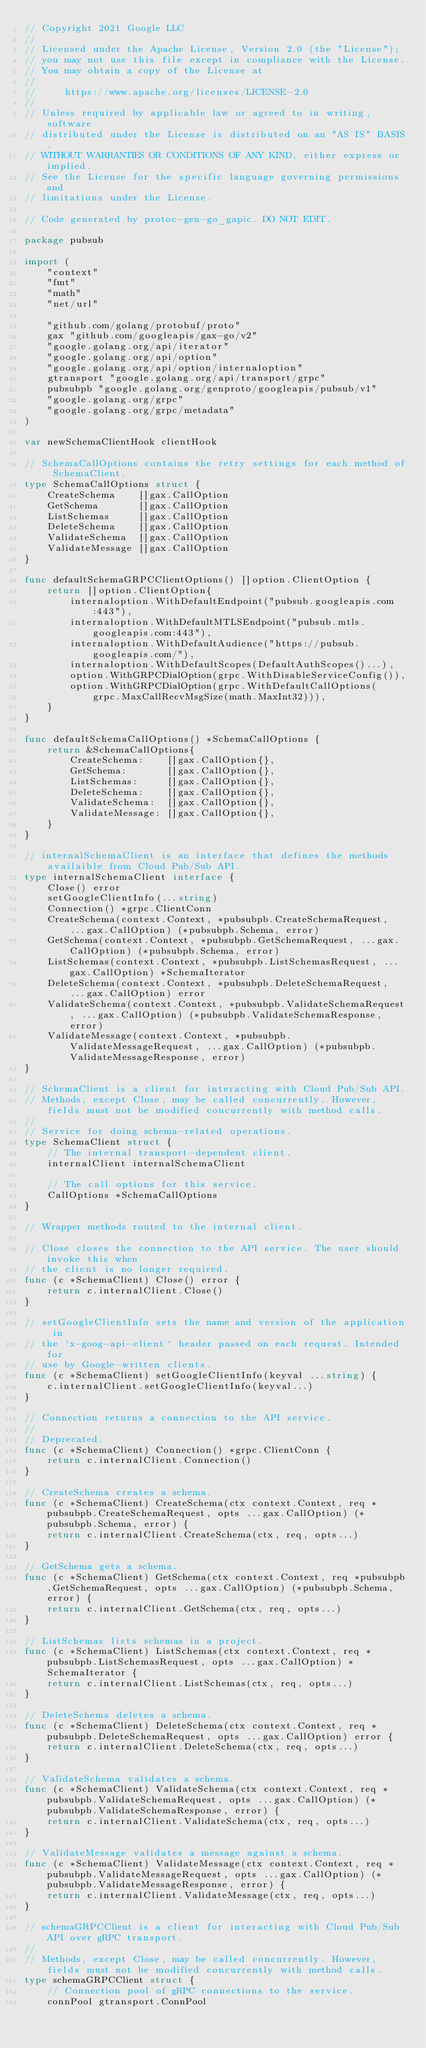Convert code to text. <code><loc_0><loc_0><loc_500><loc_500><_Go_>// Copyright 2021 Google LLC
//
// Licensed under the Apache License, Version 2.0 (the "License");
// you may not use this file except in compliance with the License.
// You may obtain a copy of the License at
//
//     https://www.apache.org/licenses/LICENSE-2.0
//
// Unless required by applicable law or agreed to in writing, software
// distributed under the License is distributed on an "AS IS" BASIS,
// WITHOUT WARRANTIES OR CONDITIONS OF ANY KIND, either express or implied.
// See the License for the specific language governing permissions and
// limitations under the License.

// Code generated by protoc-gen-go_gapic. DO NOT EDIT.

package pubsub

import (
	"context"
	"fmt"
	"math"
	"net/url"

	"github.com/golang/protobuf/proto"
	gax "github.com/googleapis/gax-go/v2"
	"google.golang.org/api/iterator"
	"google.golang.org/api/option"
	"google.golang.org/api/option/internaloption"
	gtransport "google.golang.org/api/transport/grpc"
	pubsubpb "google.golang.org/genproto/googleapis/pubsub/v1"
	"google.golang.org/grpc"
	"google.golang.org/grpc/metadata"
)

var newSchemaClientHook clientHook

// SchemaCallOptions contains the retry settings for each method of SchemaClient.
type SchemaCallOptions struct {
	CreateSchema    []gax.CallOption
	GetSchema       []gax.CallOption
	ListSchemas     []gax.CallOption
	DeleteSchema    []gax.CallOption
	ValidateSchema  []gax.CallOption
	ValidateMessage []gax.CallOption
}

func defaultSchemaGRPCClientOptions() []option.ClientOption {
	return []option.ClientOption{
		internaloption.WithDefaultEndpoint("pubsub.googleapis.com:443"),
		internaloption.WithDefaultMTLSEndpoint("pubsub.mtls.googleapis.com:443"),
		internaloption.WithDefaultAudience("https://pubsub.googleapis.com/"),
		internaloption.WithDefaultScopes(DefaultAuthScopes()...),
		option.WithGRPCDialOption(grpc.WithDisableServiceConfig()),
		option.WithGRPCDialOption(grpc.WithDefaultCallOptions(
			grpc.MaxCallRecvMsgSize(math.MaxInt32))),
	}
}

func defaultSchemaCallOptions() *SchemaCallOptions {
	return &SchemaCallOptions{
		CreateSchema:    []gax.CallOption{},
		GetSchema:       []gax.CallOption{},
		ListSchemas:     []gax.CallOption{},
		DeleteSchema:    []gax.CallOption{},
		ValidateSchema:  []gax.CallOption{},
		ValidateMessage: []gax.CallOption{},
	}
}

// internalSchemaClient is an interface that defines the methods availaible from Cloud Pub/Sub API.
type internalSchemaClient interface {
	Close() error
	setGoogleClientInfo(...string)
	Connection() *grpc.ClientConn
	CreateSchema(context.Context, *pubsubpb.CreateSchemaRequest, ...gax.CallOption) (*pubsubpb.Schema, error)
	GetSchema(context.Context, *pubsubpb.GetSchemaRequest, ...gax.CallOption) (*pubsubpb.Schema, error)
	ListSchemas(context.Context, *pubsubpb.ListSchemasRequest, ...gax.CallOption) *SchemaIterator
	DeleteSchema(context.Context, *pubsubpb.DeleteSchemaRequest, ...gax.CallOption) error
	ValidateSchema(context.Context, *pubsubpb.ValidateSchemaRequest, ...gax.CallOption) (*pubsubpb.ValidateSchemaResponse, error)
	ValidateMessage(context.Context, *pubsubpb.ValidateMessageRequest, ...gax.CallOption) (*pubsubpb.ValidateMessageResponse, error)
}

// SchemaClient is a client for interacting with Cloud Pub/Sub API.
// Methods, except Close, may be called concurrently. However, fields must not be modified concurrently with method calls.
//
// Service for doing schema-related operations.
type SchemaClient struct {
	// The internal transport-dependent client.
	internalClient internalSchemaClient

	// The call options for this service.
	CallOptions *SchemaCallOptions
}

// Wrapper methods routed to the internal client.

// Close closes the connection to the API service. The user should invoke this when
// the client is no longer required.
func (c *SchemaClient) Close() error {
	return c.internalClient.Close()
}

// setGoogleClientInfo sets the name and version of the application in
// the `x-goog-api-client` header passed on each request. Intended for
// use by Google-written clients.
func (c *SchemaClient) setGoogleClientInfo(keyval ...string) {
	c.internalClient.setGoogleClientInfo(keyval...)
}

// Connection returns a connection to the API service.
//
// Deprecated.
func (c *SchemaClient) Connection() *grpc.ClientConn {
	return c.internalClient.Connection()
}

// CreateSchema creates a schema.
func (c *SchemaClient) CreateSchema(ctx context.Context, req *pubsubpb.CreateSchemaRequest, opts ...gax.CallOption) (*pubsubpb.Schema, error) {
	return c.internalClient.CreateSchema(ctx, req, opts...)
}

// GetSchema gets a schema.
func (c *SchemaClient) GetSchema(ctx context.Context, req *pubsubpb.GetSchemaRequest, opts ...gax.CallOption) (*pubsubpb.Schema, error) {
	return c.internalClient.GetSchema(ctx, req, opts...)
}

// ListSchemas lists schemas in a project.
func (c *SchemaClient) ListSchemas(ctx context.Context, req *pubsubpb.ListSchemasRequest, opts ...gax.CallOption) *SchemaIterator {
	return c.internalClient.ListSchemas(ctx, req, opts...)
}

// DeleteSchema deletes a schema.
func (c *SchemaClient) DeleteSchema(ctx context.Context, req *pubsubpb.DeleteSchemaRequest, opts ...gax.CallOption) error {
	return c.internalClient.DeleteSchema(ctx, req, opts...)
}

// ValidateSchema validates a schema.
func (c *SchemaClient) ValidateSchema(ctx context.Context, req *pubsubpb.ValidateSchemaRequest, opts ...gax.CallOption) (*pubsubpb.ValidateSchemaResponse, error) {
	return c.internalClient.ValidateSchema(ctx, req, opts...)
}

// ValidateMessage validates a message against a schema.
func (c *SchemaClient) ValidateMessage(ctx context.Context, req *pubsubpb.ValidateMessageRequest, opts ...gax.CallOption) (*pubsubpb.ValidateMessageResponse, error) {
	return c.internalClient.ValidateMessage(ctx, req, opts...)
}

// schemaGRPCClient is a client for interacting with Cloud Pub/Sub API over gRPC transport.
//
// Methods, except Close, may be called concurrently. However, fields must not be modified concurrently with method calls.
type schemaGRPCClient struct {
	// Connection pool of gRPC connections to the service.
	connPool gtransport.ConnPool
</code> 